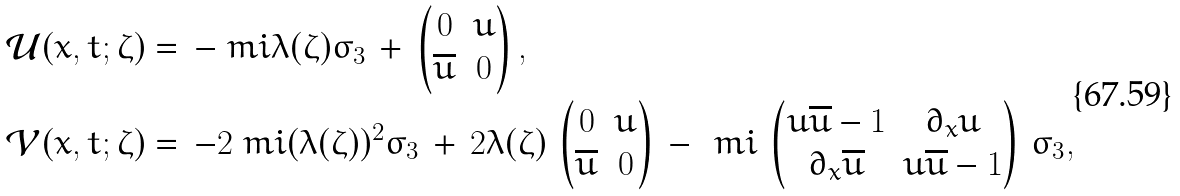<formula> <loc_0><loc_0><loc_500><loc_500>\mathcal { U } ( x , t ; \zeta ) & = \, - \ m i \lambda ( \zeta ) \sigma _ { 3 } \, + \, \begin{pmatrix} 0 & u \\ \overline { u } & 0 \end{pmatrix} , \\ \mathcal { V } ( x , t ; \zeta ) & = \, - 2 \ m i ( \lambda ( \zeta ) ) ^ { 2 } \sigma _ { 3 } \, + \, 2 \lambda ( \zeta ) \, \begin{pmatrix} 0 & u \\ \overline { u } & 0 \end{pmatrix} \, - \, \ m i \, \begin{pmatrix} u \overline { u } - 1 & \partial _ { x } u \\ \partial _ { x } \overline { u } & u \overline { u } - 1 \end{pmatrix} \, \sigma _ { 3 } ,</formula> 